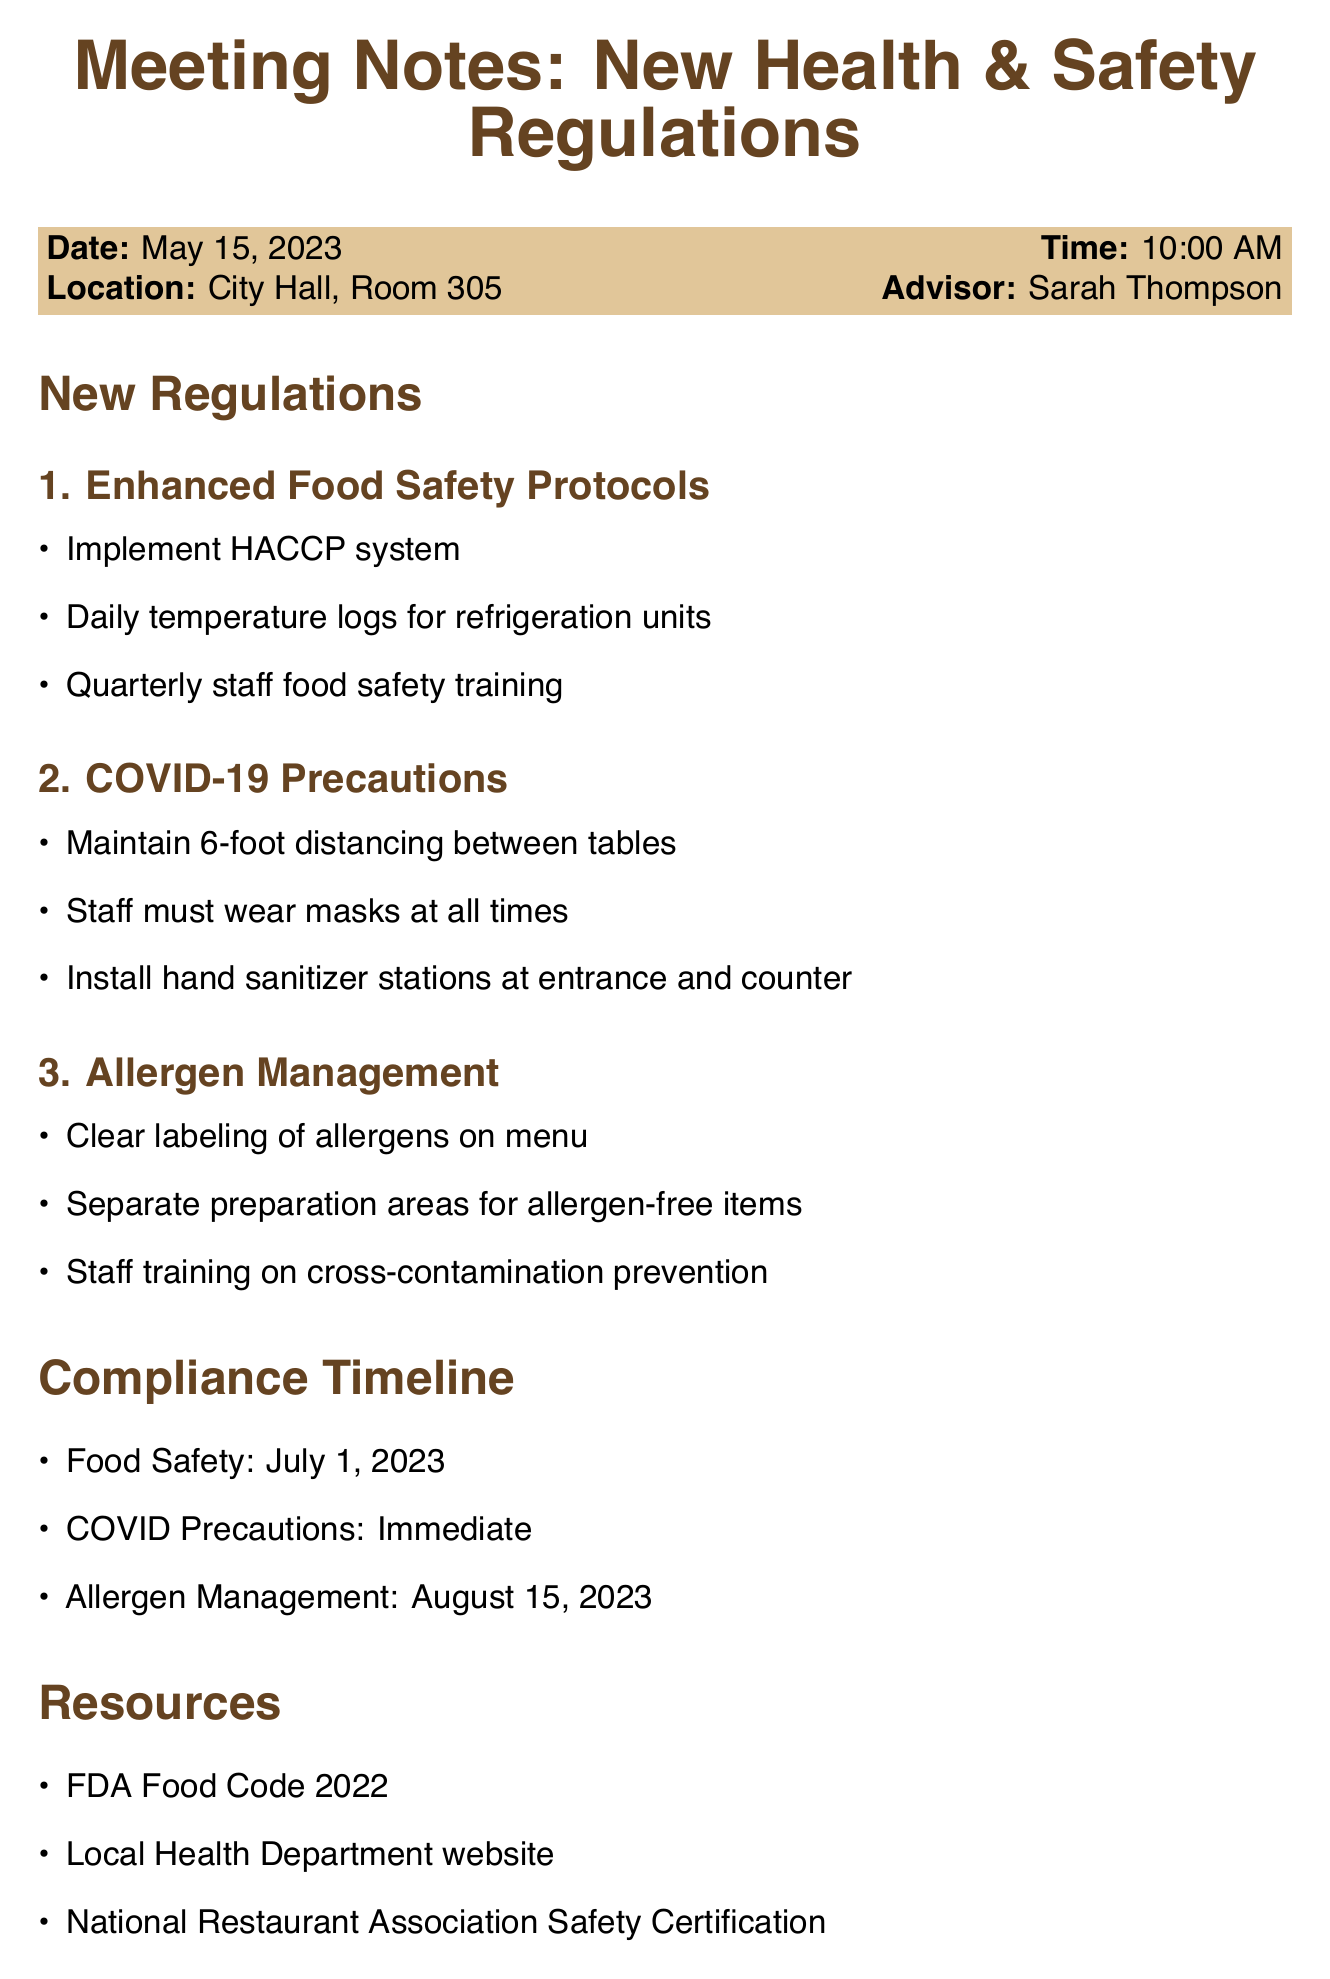what is the date of the meeting? The date of the meeting is mentioned in the meeting details section of the document.
Answer: May 15, 2023 who is the policy advisor? The advisor's name is listed in the meeting details section of the document.
Answer: Sarah Thompson what is the compliance deadline for food safety? The compliance timeline provides specific deadlines for each regulation.
Answer: July 1, 2023 how many key points are in the COVID-19 precautions section? The new regulations section lists various points, which can be counted in the COVID-19 precautions subsection.
Answer: 3 what are the resources mentioned in the document? The resources section lists various materials that can be used for further information.
Answer: FDA Food Code 2022, Local Health Department website, National Restaurant Association Safety Certification what is one follow-up action to be taken after the meeting? Follow-up actions are specifically outlined in their own section of the document.
Answer: Schedule staff training session what is the timeline for allergen management compliance? The compliance timeline specifies the deadlines for various regulations.
Answer: August 15, 2023 what question was raised regarding inspections? The questions for the advisor outline concerns regarding compliance and inspections.
Answer: Frequency of inspections? 